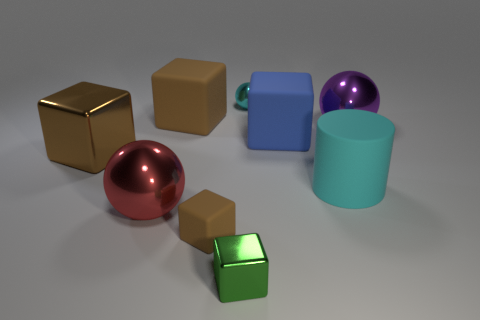There is a big sphere that is the same material as the purple object; what color is it?
Your answer should be compact. Red. Are there more large purple metallic objects than big yellow matte cylinders?
Ensure brevity in your answer.  Yes. There is a shiny object that is both on the right side of the large brown matte block and in front of the rubber cylinder; what is its size?
Provide a short and direct response. Small. There is a thing that is the same color as the big rubber cylinder; what is it made of?
Ensure brevity in your answer.  Metal. Are there an equal number of large blue rubber things that are behind the large cyan matte object and brown rubber balls?
Make the answer very short. No. Do the cylinder and the blue thing have the same size?
Your response must be concise. Yes. What color is the thing that is both on the left side of the small cyan ball and behind the blue matte block?
Offer a terse response. Brown. What is the material of the big brown thing left of the brown block that is behind the big brown metallic block?
Your response must be concise. Metal. What size is the other shiny thing that is the same shape as the brown metallic object?
Provide a succinct answer. Small. There is a big metal object on the right side of the small cyan ball; does it have the same color as the tiny metal block?
Your answer should be compact. No. 